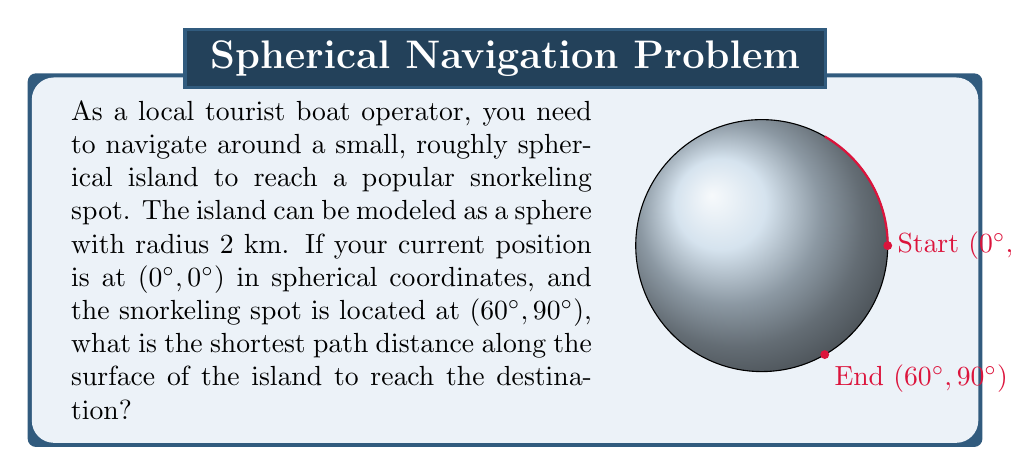Show me your answer to this math problem. To solve this problem, we need to use the concept of great circle distance on a sphere. The shortest path between two points on a sphere always lies on a great circle. We can calculate this distance using the spherical law of cosines or the Haversine formula. Let's use the spherical law of cosines for this explanation.

Step 1: Convert the coordinates to radians.
Start point: (0°, 0°) = (0, 0) radians
End point: (60°, 90°) = ($\frac{\pi}{3}$, $\frac{\pi}{2}$) radians

Step 2: Apply the spherical law of cosines formula:
$$\cos(c) = \sin(a)\sin(b) + \cos(a)\cos(b)\cos(C)$$
Where:
$a$ and $b$ are the latitudes of the two points
$C$ is the difference in longitude
$c$ is the central angle (in radians) between the points

$$\cos(c) = \sin(0)\sin(\frac{\pi}{3}) + \cos(0)\cos(\frac{\pi}{3})\cos(\frac{\pi}{2})$$

Step 3: Simplify the equation:
$$\cos(c) = 0 + \cos(\frac{\pi}{3}) \cdot 0 = 0$$

Step 4: Solve for $c$:
$$c = \arccos(0) = \frac{\pi}{2}$$ radians

Step 5: Calculate the distance along the surface:
Distance = Radius × Central Angle
$$d = 2 \cdot \frac{\pi}{2} = \pi$$ km

Therefore, the shortest path distance along the surface of the island is $\pi$ km or approximately 3.14 km.
Answer: $\pi$ km 